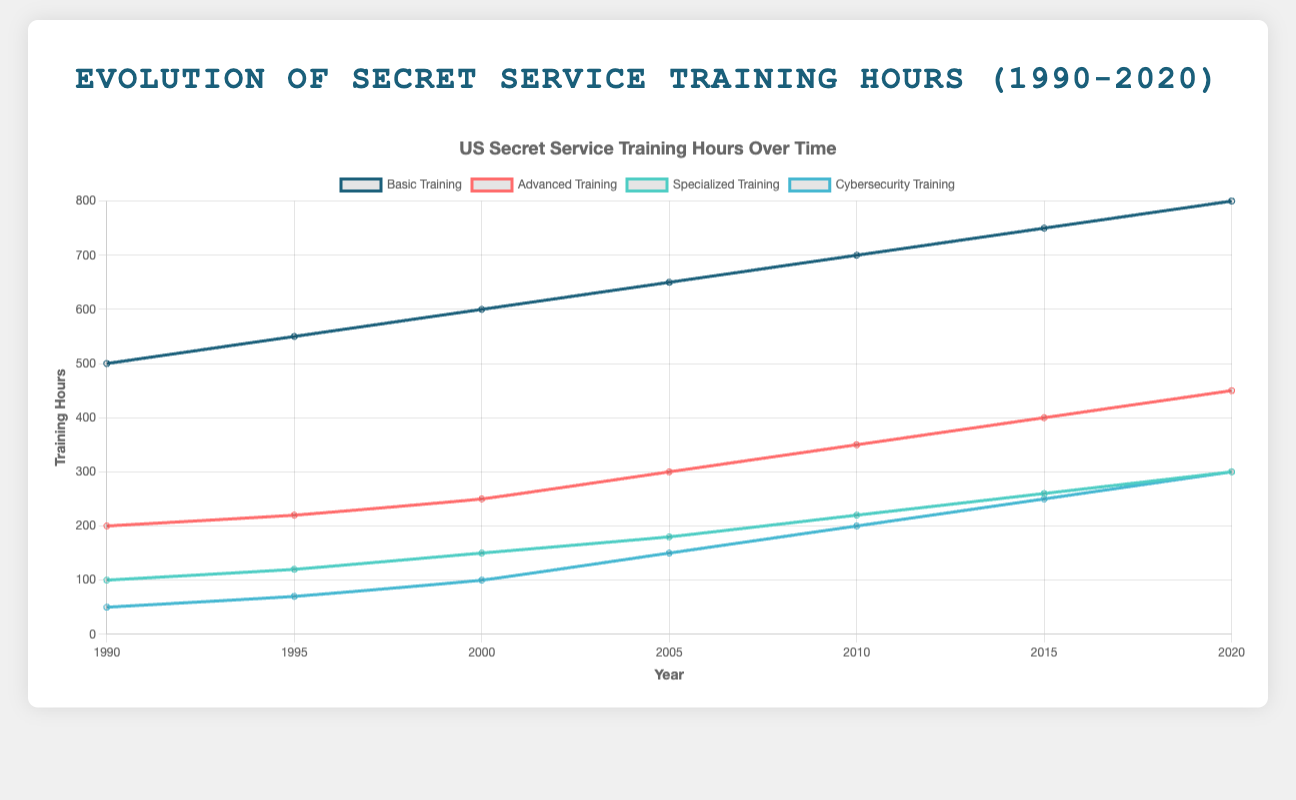What type of training had the most significant increase in hours from 1990 to 2020? The Cybersecurity Training increased from 50 hours in 1990 to 300 hours in 2020. To find the increase, subtract 50 from 300, which results in an increase of 250 hours, the largest increase among all training types.
Answer: Cybersecurity Training Between Basic Training and Advanced Training, which one saw a greater cumulative increase from 1990 to 2020? Basic Training increased from 500 hours in 1990 to 800 hours in 2020, an increase of 300 hours. Advanced Training increased from 200 hours in 1990 to 450 hours in 2020, an increase of 250 hours. Comparing these increases, Basic Training had a greater cumulative increase.
Answer: Basic Training By how many hours did Specialized Training increase from 2000 to 2015? In 2000, Specialized Training was 150 hours and in 2015 it was 260 hours. Subtracting 150 from 260 gives an increase of 110 hours.
Answer: 110 hours Which training type had the smallest increase in hours between 1990 and 1995? Basic Training increased by 50 hours (from 500 to 550), Advanced Training by 20 hours (from 200 to 220), Specialized Training by 20 hours (from 100 to 120), and Cybersecurity Training by 20 hours (from 50 to 70). Since 20 hours is the smallest increase shared by Advanced, Specialized, and Cybersecurity Training, choose any for the answer.
Answer: Advanced, Specialized, or Cybersecurity Training What is the average increase per year in hours for Advanced Training from 1990 to 2020? From 1990 to 2020, Advanced Training increased from 200 hours to 450 hours. This is an increase of 250 hours over 30 years. To find the average increase per year, divide 250 by 30, which equals approximately 8.33 hours per year.
Answer: ~8.33 hours per year Compare the training hours for Basic Training and Specialized Training in 2010. Which was higher and by how much? In 2010, Basic Training was 700 hours and Specialized Training was 220 hours. The difference is 700 - 220 = 480 hours, with Basic Training being higher by this amount.
Answer: Basic Training by 480 hours What trend can be observed in the changes of training hours for Cybersecurity Training from 2005 to 2020? In 2005, Cybersecurity Training was 150 hours. This increased steadily to 300 hours by 2020. The trend shows a gradual and consistent increase in Cybersecurity Training hours over these years.
Answer: Gradual and consistent increase Which year saw the most significant change in training hours for any training type? Comparing the intervals, from 2000 to 2005, Specialized Training increased by 30 hours. Between 2005 and 2010, it increased by 40 hours, which is the highest change observed in any interval for all training types.
Answer: Between 2005 and 2010 for Specialized Training 